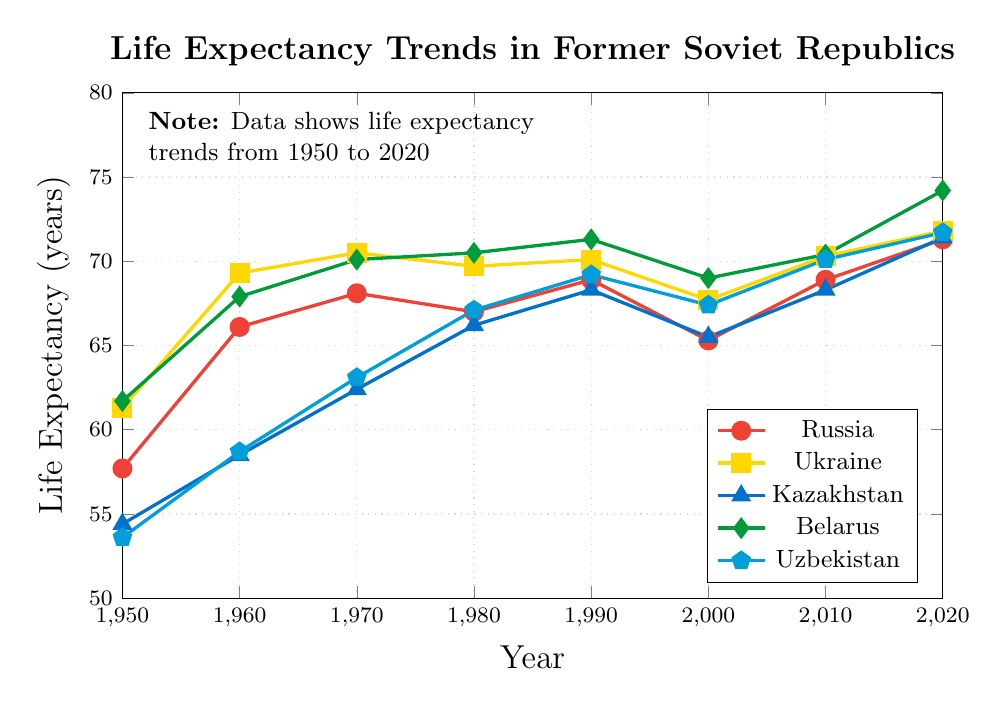Which country had the highest life expectancy in 2020? By looking at the values in 2020, compare the life expectancy values for all countries. Belarus had a life expectancy of 74.2, which is the highest among the listed countries.
Answer: Belarus How did the life expectancy in Russia change from 1950 to 2020? The life expectancy in Russia started at 57.7 in 1950 and increased to 71.3 in 2020. Calculate the difference: 71.3 - 57.7 = 13.6.
Answer: Increased by 13.6 years Compare the life expectancy of Ukraine and Kazakhstan in 1990. Which was higher? Check the life expectancy values for Ukraine and Kazakhstan in 1990. Ukraine had 70.1 and Kazakhstan had 68.3. Hence, Ukraine's life expectancy was higher.
Answer: Ukraine What is the overall trend for life expectancy in Uzbekistan from 1950 to 2020? Observe the values for Uzbekistan from 1950 (53.6) to 2020 (71.7). There is a clear increasing trend over the years.
Answer: Increasing Which country's life expectancy was the lowest in 1950? By comparing the life expectancy values in 1950 for all countries, Kazakhstan had the lowest value at 54.4.
Answer: Kazakhstan What is the average life expectancy in Belarus from 1950 to 2020? Find the life expectancy values for Belarus in all provided years: (61.7, 67.9, 70.1, 70.5, 71.3, 69.0, 70.4, 74.2). Calculate the sum of these values and divide by the number of values. Sum = 555.1, Number of values = 8, Average = 555.1 / 8 = 69.4
Answer: 69.4 Compare the life expectancy trend of Russia and Ukraine from 2000 to 2020. Which country had a larger increase? Look at the values for Russia and Ukraine in 2000 (Russia: 65.3, Ukraine: 67.7) and in 2020 (Russia: 71.3, Ukraine: 71.8). Calculate the difference for both countries: Russia: 71.3 - 65.3 = 6, Ukraine: 71.8 - 67.7 = 4.1. Russia had a larger increase.
Answer: Russia Between which consecutive decades did Kazakhstan see the greatest increase in life expectancy? Calculate the difference in life expectancy for Kazakhstan between each consecutive decade: 1950-1960: 58.5 - 54.4 = 4.1, 1960-1970: 62.4 - 58.5 = 3.9, 1970-1980: 66.2 - 62.4 = 3.8, 1980-1990: 68.3 - 66.2 = 2.1, 1990-2000: 65.5 - 68.3 = -2.8, 2000-2010: 68.3 - 65.5 = 2.8, 2010-2020: 71.4 - 68.3 = 3.1. The greatest increase happened between 1950-1960 with an increase of 4.1.
Answer: 1950-1960 Which country had the smallest decrease in life expectancy between 1990 and 2000? Calculate the decrease in life expectancy for each country between 1990 and 2000: Russia: 68.9 - 65.3 = 3.6, Ukraine: 70.1 - 67.7 = 2.4, Kazakhstan: 68.3 - 65.5 = 2.8, Belarus: 71.3 - 69.0 = 2.3, Uzbekistan: 69.2 - 67.4 = 1.8. Uzbekistan had the smallest decrease of 1.8.
Answer: Uzbekistan 